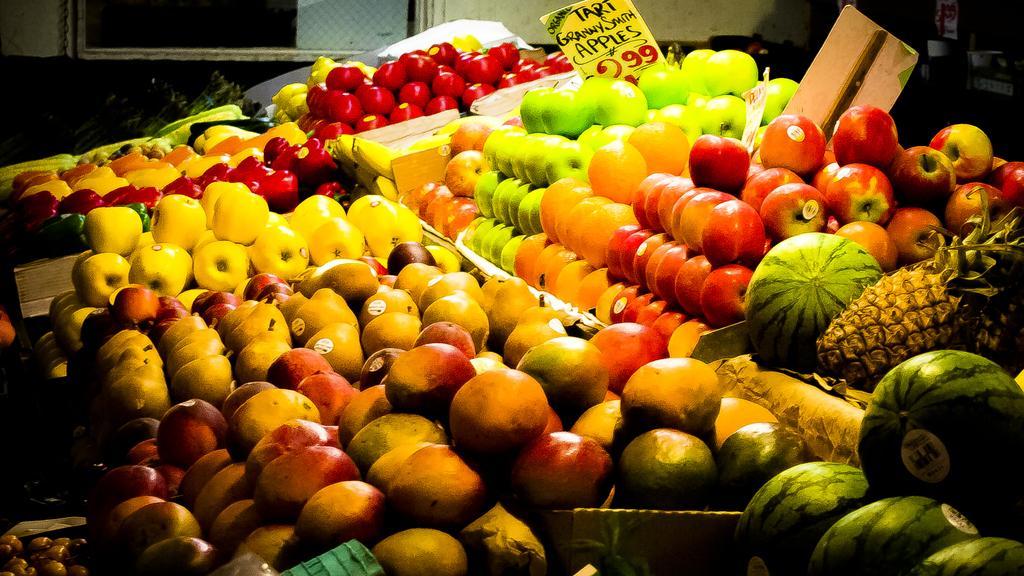Could you give a brief overview of what you see in this image? In this picture we can see few apples, watermelons, pineapple and other fruits in the plates, and also we can see few boards. 